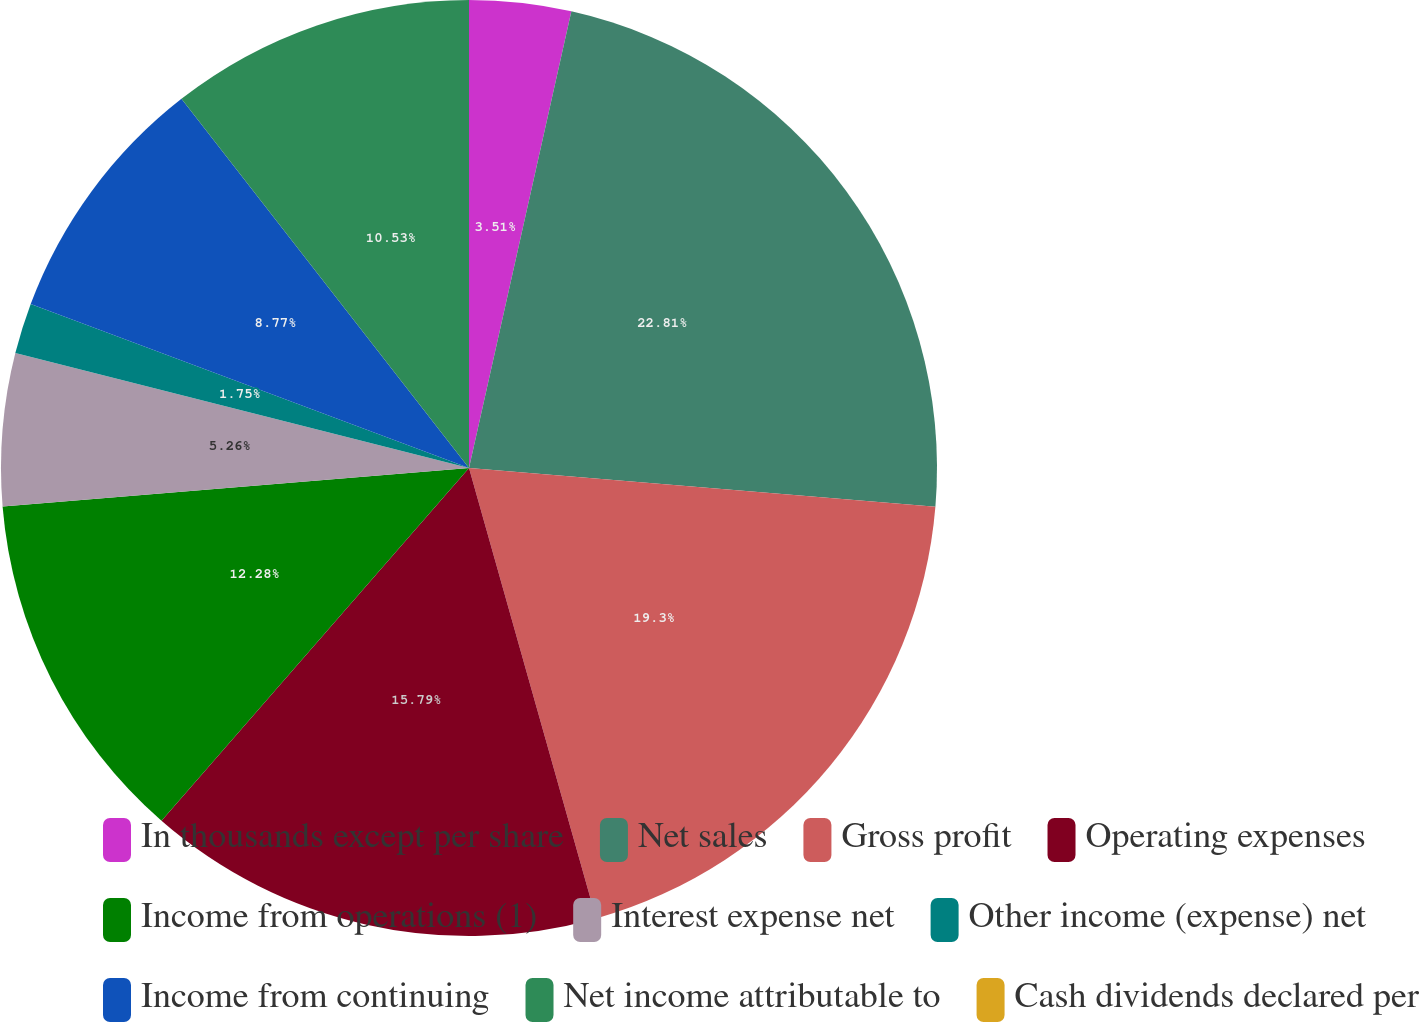Convert chart. <chart><loc_0><loc_0><loc_500><loc_500><pie_chart><fcel>In thousands except per share<fcel>Net sales<fcel>Gross profit<fcel>Operating expenses<fcel>Income from operations (1)<fcel>Interest expense net<fcel>Other income (expense) net<fcel>Income from continuing<fcel>Net income attributable to<fcel>Cash dividends declared per<nl><fcel>3.51%<fcel>22.81%<fcel>19.3%<fcel>15.79%<fcel>12.28%<fcel>5.26%<fcel>1.75%<fcel>8.77%<fcel>10.53%<fcel>0.0%<nl></chart> 